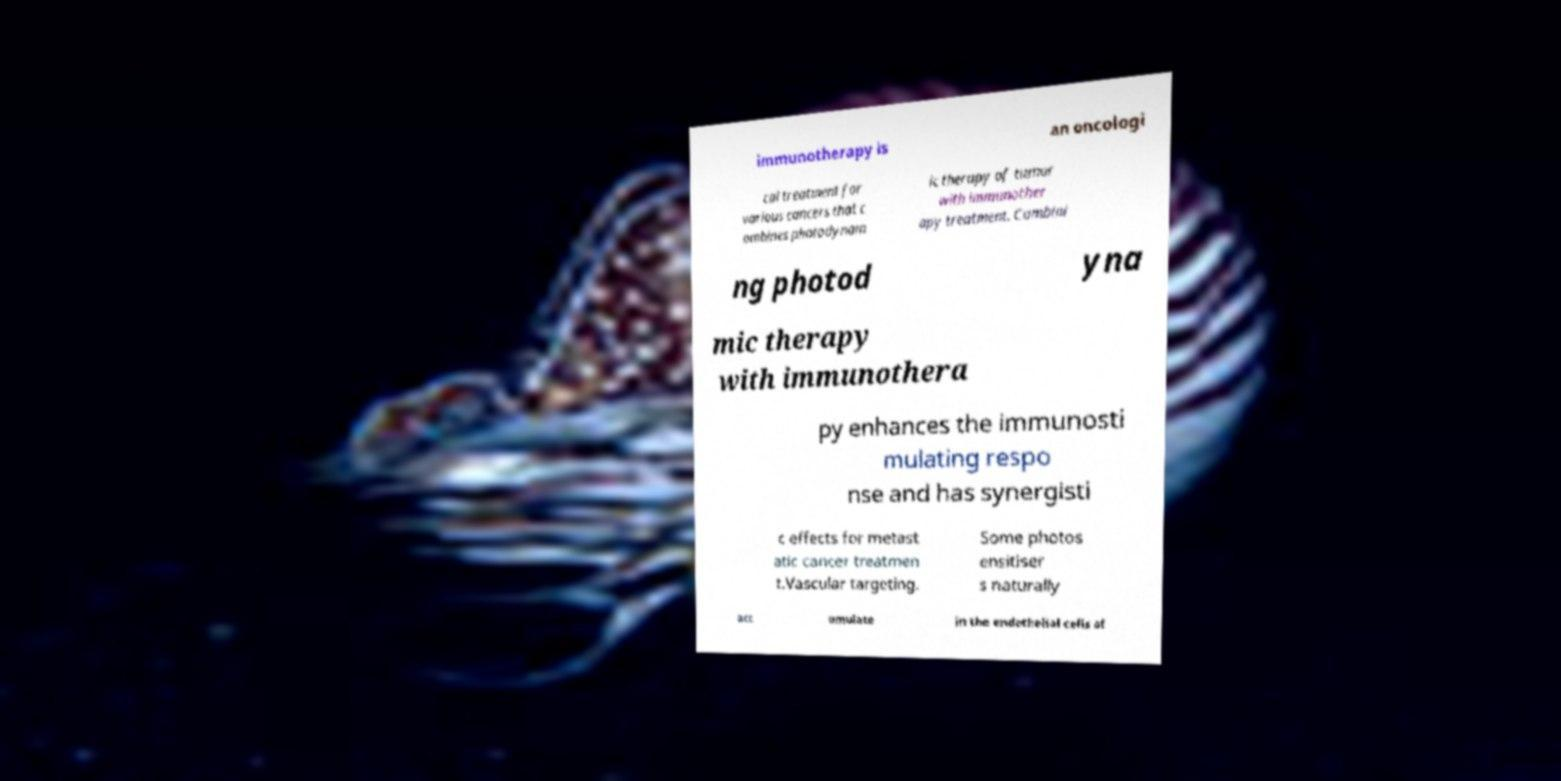I need the written content from this picture converted into text. Can you do that? immunotherapy is an oncologi cal treatment for various cancers that c ombines photodynam ic therapy of tumor with immunother apy treatment. Combini ng photod yna mic therapy with immunothera py enhances the immunosti mulating respo nse and has synergisti c effects for metast atic cancer treatmen t.Vascular targeting. Some photos ensitiser s naturally acc umulate in the endothelial cells of 